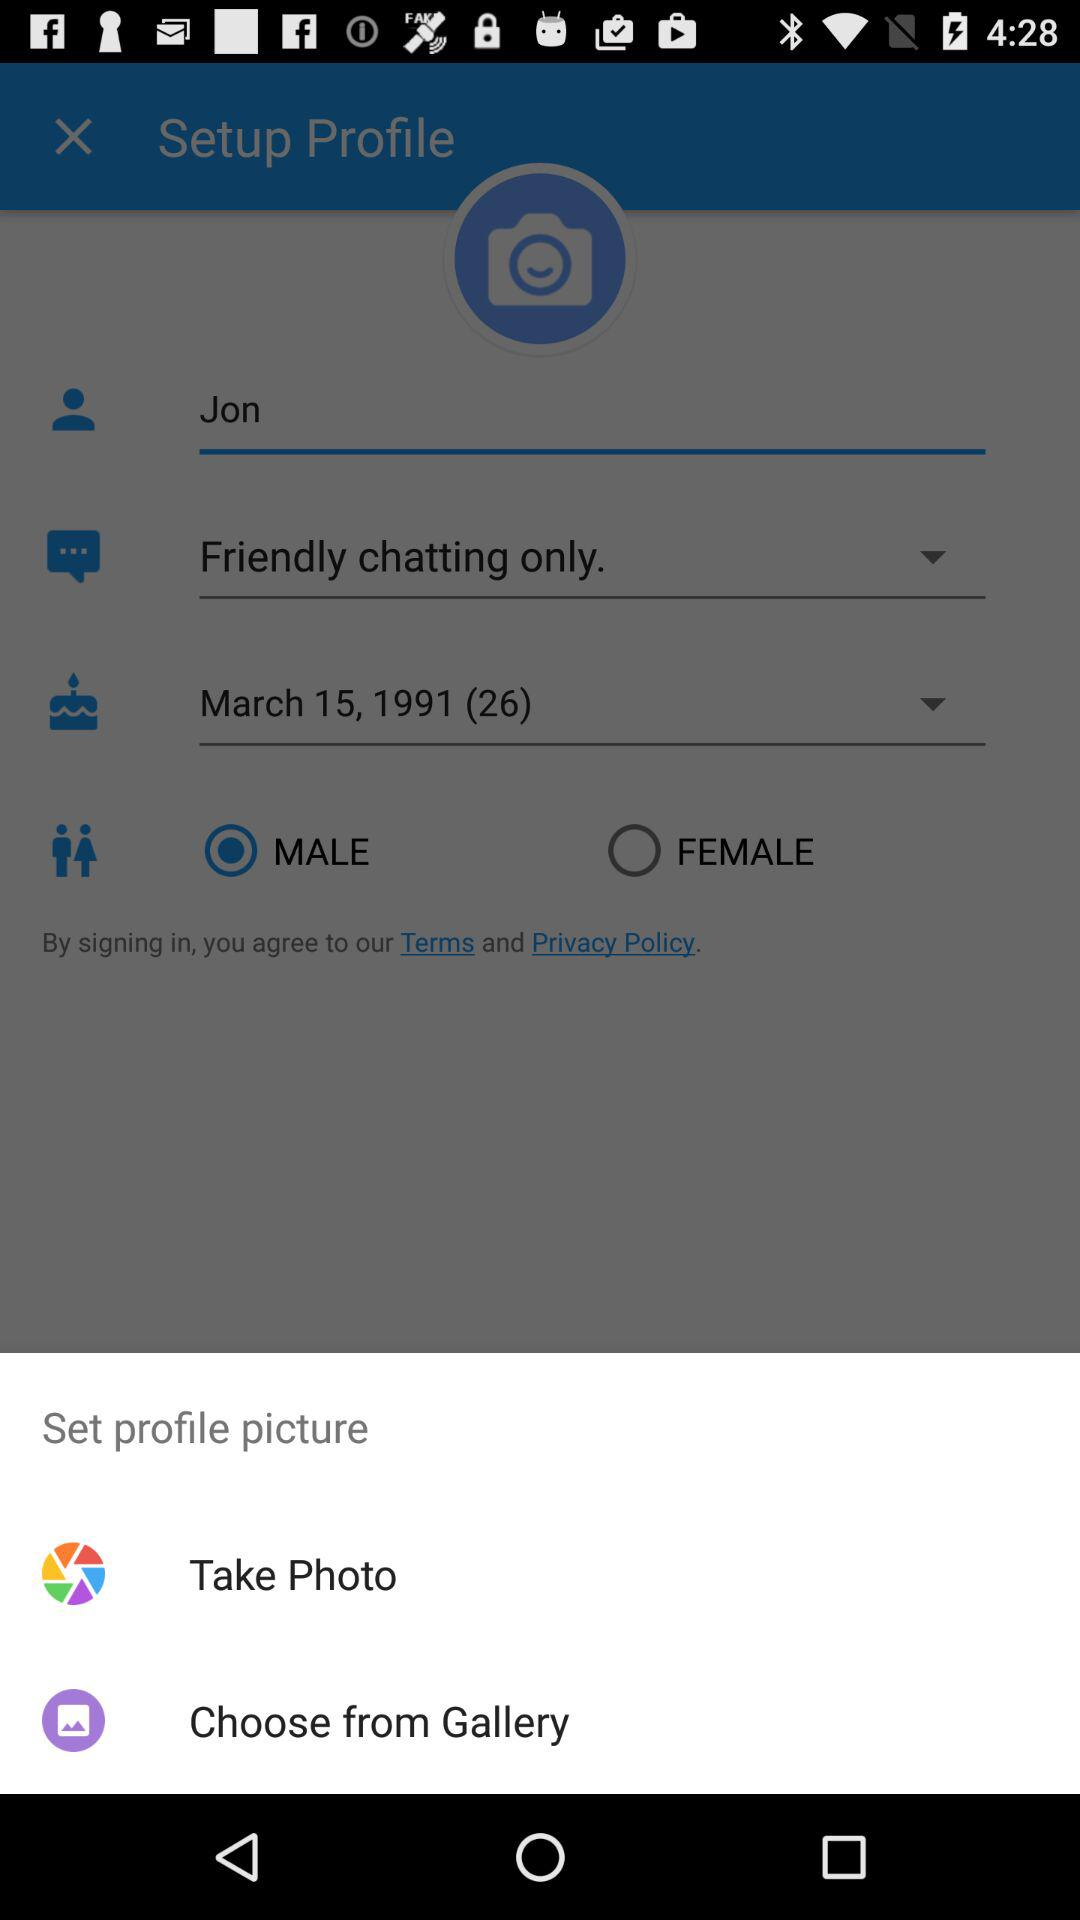What is the name of the user? The name of the user is Jon. 